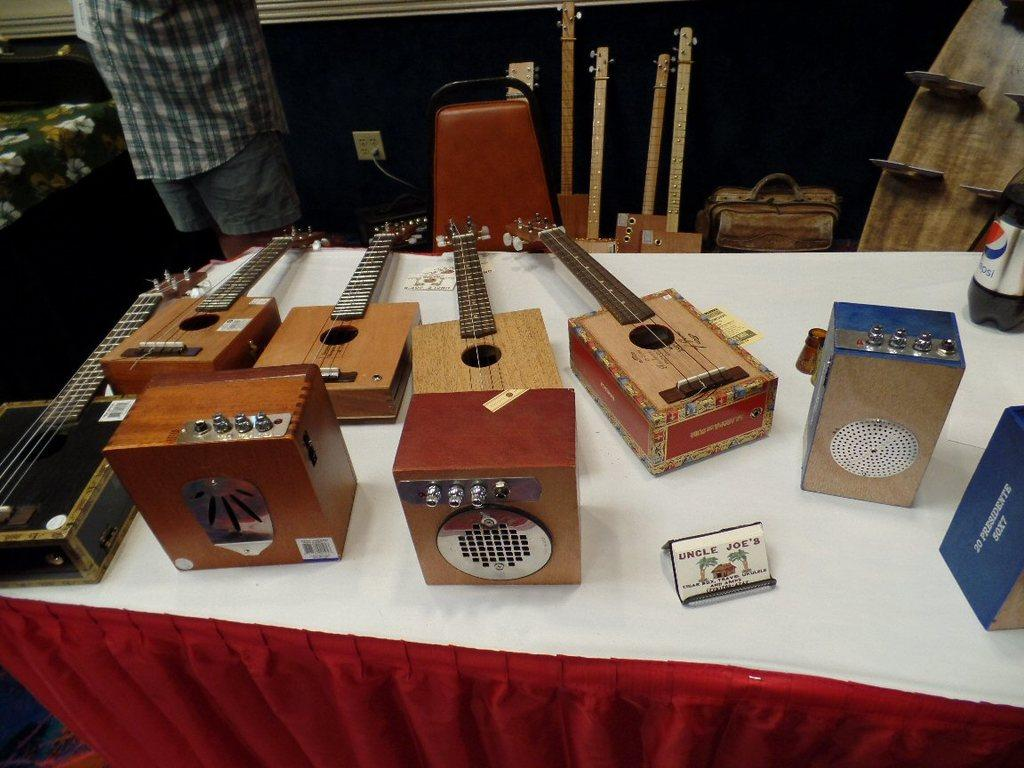What is the main subject of the image? There is a man in the image. What object is present in the image that the man might use for sitting? There is a chair in the image. What other items can be seen in the image besides the man and the chair? There are musical instruments in the image. What type of stitch is the man using to play the musical instruments in the image? There is no stitching involved in playing musical instruments, and the man is not using any stitching in the image. 